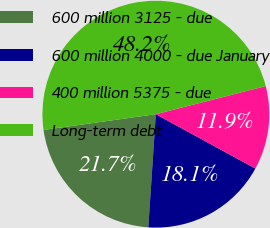<chart> <loc_0><loc_0><loc_500><loc_500><pie_chart><fcel>600 million 3125 - due<fcel>600 million 4000 - due January<fcel>400 million 5375 - due<fcel>Long-term debt<nl><fcel>21.72%<fcel>18.1%<fcel>11.94%<fcel>48.24%<nl></chart> 